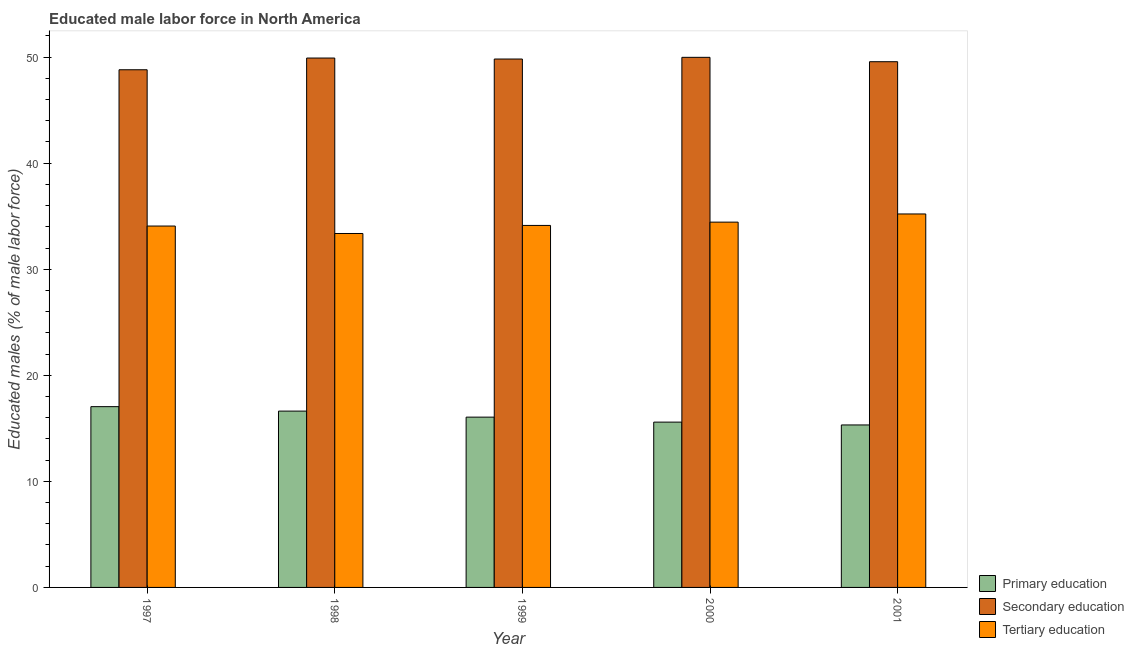How many groups of bars are there?
Your answer should be very brief. 5. Are the number of bars per tick equal to the number of legend labels?
Your answer should be very brief. Yes. Are the number of bars on each tick of the X-axis equal?
Ensure brevity in your answer.  Yes. How many bars are there on the 4th tick from the left?
Provide a succinct answer. 3. How many bars are there on the 5th tick from the right?
Ensure brevity in your answer.  3. What is the label of the 2nd group of bars from the left?
Keep it short and to the point. 1998. In how many cases, is the number of bars for a given year not equal to the number of legend labels?
Your answer should be very brief. 0. What is the percentage of male labor force who received secondary education in 2000?
Ensure brevity in your answer.  49.98. Across all years, what is the maximum percentage of male labor force who received primary education?
Provide a short and direct response. 17.04. Across all years, what is the minimum percentage of male labor force who received secondary education?
Your answer should be compact. 48.81. In which year was the percentage of male labor force who received secondary education minimum?
Your answer should be compact. 1997. What is the total percentage of male labor force who received secondary education in the graph?
Offer a very short reply. 248.07. What is the difference between the percentage of male labor force who received secondary education in 1998 and that in 1999?
Your response must be concise. 0.09. What is the difference between the percentage of male labor force who received primary education in 1997 and the percentage of male labor force who received tertiary education in 1998?
Your response must be concise. 0.42. What is the average percentage of male labor force who received tertiary education per year?
Your answer should be very brief. 34.24. In the year 1999, what is the difference between the percentage of male labor force who received primary education and percentage of male labor force who received tertiary education?
Your response must be concise. 0. What is the ratio of the percentage of male labor force who received tertiary education in 1998 to that in 2000?
Offer a very short reply. 0.97. What is the difference between the highest and the second highest percentage of male labor force who received tertiary education?
Your answer should be very brief. 0.77. What is the difference between the highest and the lowest percentage of male labor force who received primary education?
Offer a terse response. 1.73. In how many years, is the percentage of male labor force who received secondary education greater than the average percentage of male labor force who received secondary education taken over all years?
Give a very brief answer. 3. What does the 3rd bar from the left in 1998 represents?
Offer a very short reply. Tertiary education. What does the 2nd bar from the right in 1998 represents?
Ensure brevity in your answer.  Secondary education. Is it the case that in every year, the sum of the percentage of male labor force who received primary education and percentage of male labor force who received secondary education is greater than the percentage of male labor force who received tertiary education?
Your response must be concise. Yes. Are all the bars in the graph horizontal?
Ensure brevity in your answer.  No. How many years are there in the graph?
Ensure brevity in your answer.  5. Where does the legend appear in the graph?
Keep it short and to the point. Bottom right. How many legend labels are there?
Make the answer very short. 3. How are the legend labels stacked?
Offer a very short reply. Vertical. What is the title of the graph?
Provide a short and direct response. Educated male labor force in North America. What is the label or title of the X-axis?
Give a very brief answer. Year. What is the label or title of the Y-axis?
Make the answer very short. Educated males (% of male labor force). What is the Educated males (% of male labor force) in Primary education in 1997?
Your response must be concise. 17.04. What is the Educated males (% of male labor force) of Secondary education in 1997?
Provide a short and direct response. 48.81. What is the Educated males (% of male labor force) in Tertiary education in 1997?
Make the answer very short. 34.07. What is the Educated males (% of male labor force) in Primary education in 1998?
Ensure brevity in your answer.  16.62. What is the Educated males (% of male labor force) in Secondary education in 1998?
Make the answer very short. 49.91. What is the Educated males (% of male labor force) in Tertiary education in 1998?
Provide a succinct answer. 33.37. What is the Educated males (% of male labor force) of Primary education in 1999?
Ensure brevity in your answer.  16.05. What is the Educated males (% of male labor force) of Secondary education in 1999?
Offer a very short reply. 49.82. What is the Educated males (% of male labor force) in Tertiary education in 1999?
Your answer should be compact. 34.13. What is the Educated males (% of male labor force) in Primary education in 2000?
Your answer should be very brief. 15.59. What is the Educated males (% of male labor force) of Secondary education in 2000?
Your response must be concise. 49.98. What is the Educated males (% of male labor force) of Tertiary education in 2000?
Provide a succinct answer. 34.44. What is the Educated males (% of male labor force) in Primary education in 2001?
Give a very brief answer. 15.32. What is the Educated males (% of male labor force) in Secondary education in 2001?
Your answer should be compact. 49.56. What is the Educated males (% of male labor force) in Tertiary education in 2001?
Your answer should be compact. 35.21. Across all years, what is the maximum Educated males (% of male labor force) of Primary education?
Your answer should be compact. 17.04. Across all years, what is the maximum Educated males (% of male labor force) in Secondary education?
Your answer should be very brief. 49.98. Across all years, what is the maximum Educated males (% of male labor force) of Tertiary education?
Make the answer very short. 35.21. Across all years, what is the minimum Educated males (% of male labor force) of Primary education?
Your response must be concise. 15.32. Across all years, what is the minimum Educated males (% of male labor force) in Secondary education?
Make the answer very short. 48.81. Across all years, what is the minimum Educated males (% of male labor force) of Tertiary education?
Make the answer very short. 33.37. What is the total Educated males (% of male labor force) of Primary education in the graph?
Give a very brief answer. 80.62. What is the total Educated males (% of male labor force) of Secondary education in the graph?
Offer a very short reply. 248.07. What is the total Educated males (% of male labor force) in Tertiary education in the graph?
Your answer should be very brief. 171.22. What is the difference between the Educated males (% of male labor force) of Primary education in 1997 and that in 1998?
Give a very brief answer. 0.42. What is the difference between the Educated males (% of male labor force) in Secondary education in 1997 and that in 1998?
Offer a terse response. -1.1. What is the difference between the Educated males (% of male labor force) in Tertiary education in 1997 and that in 1998?
Give a very brief answer. 0.7. What is the difference between the Educated males (% of male labor force) in Secondary education in 1997 and that in 1999?
Offer a very short reply. -1.01. What is the difference between the Educated males (% of male labor force) of Tertiary education in 1997 and that in 1999?
Give a very brief answer. -0.06. What is the difference between the Educated males (% of male labor force) in Primary education in 1997 and that in 2000?
Provide a succinct answer. 1.46. What is the difference between the Educated males (% of male labor force) of Secondary education in 1997 and that in 2000?
Your answer should be compact. -1.17. What is the difference between the Educated males (% of male labor force) in Tertiary education in 1997 and that in 2000?
Offer a very short reply. -0.37. What is the difference between the Educated males (% of male labor force) in Primary education in 1997 and that in 2001?
Your answer should be very brief. 1.73. What is the difference between the Educated males (% of male labor force) in Secondary education in 1997 and that in 2001?
Offer a very short reply. -0.76. What is the difference between the Educated males (% of male labor force) of Tertiary education in 1997 and that in 2001?
Give a very brief answer. -1.14. What is the difference between the Educated males (% of male labor force) in Primary education in 1998 and that in 1999?
Your answer should be compact. 0.57. What is the difference between the Educated males (% of male labor force) of Secondary education in 1998 and that in 1999?
Your response must be concise. 0.09. What is the difference between the Educated males (% of male labor force) of Tertiary education in 1998 and that in 1999?
Offer a terse response. -0.76. What is the difference between the Educated males (% of male labor force) in Primary education in 1998 and that in 2000?
Your answer should be compact. 1.04. What is the difference between the Educated males (% of male labor force) in Secondary education in 1998 and that in 2000?
Give a very brief answer. -0.07. What is the difference between the Educated males (% of male labor force) in Tertiary education in 1998 and that in 2000?
Your answer should be very brief. -1.07. What is the difference between the Educated males (% of male labor force) in Primary education in 1998 and that in 2001?
Your answer should be very brief. 1.31. What is the difference between the Educated males (% of male labor force) of Secondary education in 1998 and that in 2001?
Your response must be concise. 0.35. What is the difference between the Educated males (% of male labor force) in Tertiary education in 1998 and that in 2001?
Provide a succinct answer. -1.84. What is the difference between the Educated males (% of male labor force) of Primary education in 1999 and that in 2000?
Offer a very short reply. 0.47. What is the difference between the Educated males (% of male labor force) in Secondary education in 1999 and that in 2000?
Offer a very short reply. -0.16. What is the difference between the Educated males (% of male labor force) of Tertiary education in 1999 and that in 2000?
Make the answer very short. -0.31. What is the difference between the Educated males (% of male labor force) of Primary education in 1999 and that in 2001?
Your answer should be compact. 0.74. What is the difference between the Educated males (% of male labor force) of Secondary education in 1999 and that in 2001?
Provide a succinct answer. 0.25. What is the difference between the Educated males (% of male labor force) of Tertiary education in 1999 and that in 2001?
Your answer should be very brief. -1.08. What is the difference between the Educated males (% of male labor force) of Primary education in 2000 and that in 2001?
Provide a short and direct response. 0.27. What is the difference between the Educated males (% of male labor force) in Secondary education in 2000 and that in 2001?
Provide a succinct answer. 0.41. What is the difference between the Educated males (% of male labor force) of Tertiary education in 2000 and that in 2001?
Offer a terse response. -0.77. What is the difference between the Educated males (% of male labor force) of Primary education in 1997 and the Educated males (% of male labor force) of Secondary education in 1998?
Keep it short and to the point. -32.87. What is the difference between the Educated males (% of male labor force) of Primary education in 1997 and the Educated males (% of male labor force) of Tertiary education in 1998?
Give a very brief answer. -16.32. What is the difference between the Educated males (% of male labor force) in Secondary education in 1997 and the Educated males (% of male labor force) in Tertiary education in 1998?
Provide a succinct answer. 15.44. What is the difference between the Educated males (% of male labor force) of Primary education in 1997 and the Educated males (% of male labor force) of Secondary education in 1999?
Keep it short and to the point. -32.77. What is the difference between the Educated males (% of male labor force) in Primary education in 1997 and the Educated males (% of male labor force) in Tertiary education in 1999?
Ensure brevity in your answer.  -17.08. What is the difference between the Educated males (% of male labor force) in Secondary education in 1997 and the Educated males (% of male labor force) in Tertiary education in 1999?
Offer a very short reply. 14.68. What is the difference between the Educated males (% of male labor force) of Primary education in 1997 and the Educated males (% of male labor force) of Secondary education in 2000?
Give a very brief answer. -32.93. What is the difference between the Educated males (% of male labor force) of Primary education in 1997 and the Educated males (% of male labor force) of Tertiary education in 2000?
Offer a terse response. -17.39. What is the difference between the Educated males (% of male labor force) of Secondary education in 1997 and the Educated males (% of male labor force) of Tertiary education in 2000?
Your answer should be compact. 14.37. What is the difference between the Educated males (% of male labor force) in Primary education in 1997 and the Educated males (% of male labor force) in Secondary education in 2001?
Offer a terse response. -32.52. What is the difference between the Educated males (% of male labor force) in Primary education in 1997 and the Educated males (% of male labor force) in Tertiary education in 2001?
Your response must be concise. -18.17. What is the difference between the Educated males (% of male labor force) of Secondary education in 1997 and the Educated males (% of male labor force) of Tertiary education in 2001?
Give a very brief answer. 13.6. What is the difference between the Educated males (% of male labor force) in Primary education in 1998 and the Educated males (% of male labor force) in Secondary education in 1999?
Give a very brief answer. -33.19. What is the difference between the Educated males (% of male labor force) of Primary education in 1998 and the Educated males (% of male labor force) of Tertiary education in 1999?
Offer a terse response. -17.51. What is the difference between the Educated males (% of male labor force) in Secondary education in 1998 and the Educated males (% of male labor force) in Tertiary education in 1999?
Keep it short and to the point. 15.78. What is the difference between the Educated males (% of male labor force) in Primary education in 1998 and the Educated males (% of male labor force) in Secondary education in 2000?
Provide a short and direct response. -33.35. What is the difference between the Educated males (% of male labor force) in Primary education in 1998 and the Educated males (% of male labor force) in Tertiary education in 2000?
Provide a succinct answer. -17.82. What is the difference between the Educated males (% of male labor force) of Secondary education in 1998 and the Educated males (% of male labor force) of Tertiary education in 2000?
Offer a very short reply. 15.47. What is the difference between the Educated males (% of male labor force) of Primary education in 1998 and the Educated males (% of male labor force) of Secondary education in 2001?
Give a very brief answer. -32.94. What is the difference between the Educated males (% of male labor force) in Primary education in 1998 and the Educated males (% of male labor force) in Tertiary education in 2001?
Offer a terse response. -18.59. What is the difference between the Educated males (% of male labor force) of Secondary education in 1998 and the Educated males (% of male labor force) of Tertiary education in 2001?
Your response must be concise. 14.7. What is the difference between the Educated males (% of male labor force) of Primary education in 1999 and the Educated males (% of male labor force) of Secondary education in 2000?
Offer a terse response. -33.92. What is the difference between the Educated males (% of male labor force) in Primary education in 1999 and the Educated males (% of male labor force) in Tertiary education in 2000?
Keep it short and to the point. -18.38. What is the difference between the Educated males (% of male labor force) in Secondary education in 1999 and the Educated males (% of male labor force) in Tertiary education in 2000?
Provide a succinct answer. 15.38. What is the difference between the Educated males (% of male labor force) of Primary education in 1999 and the Educated males (% of male labor force) of Secondary education in 2001?
Make the answer very short. -33.51. What is the difference between the Educated males (% of male labor force) in Primary education in 1999 and the Educated males (% of male labor force) in Tertiary education in 2001?
Your answer should be compact. -19.15. What is the difference between the Educated males (% of male labor force) in Secondary education in 1999 and the Educated males (% of male labor force) in Tertiary education in 2001?
Your answer should be compact. 14.61. What is the difference between the Educated males (% of male labor force) in Primary education in 2000 and the Educated males (% of male labor force) in Secondary education in 2001?
Offer a terse response. -33.98. What is the difference between the Educated males (% of male labor force) of Primary education in 2000 and the Educated males (% of male labor force) of Tertiary education in 2001?
Your response must be concise. -19.62. What is the difference between the Educated males (% of male labor force) in Secondary education in 2000 and the Educated males (% of male labor force) in Tertiary education in 2001?
Your response must be concise. 14.77. What is the average Educated males (% of male labor force) of Primary education per year?
Provide a short and direct response. 16.12. What is the average Educated males (% of male labor force) in Secondary education per year?
Your answer should be compact. 49.61. What is the average Educated males (% of male labor force) in Tertiary education per year?
Make the answer very short. 34.24. In the year 1997, what is the difference between the Educated males (% of male labor force) of Primary education and Educated males (% of male labor force) of Secondary education?
Your answer should be very brief. -31.76. In the year 1997, what is the difference between the Educated males (% of male labor force) in Primary education and Educated males (% of male labor force) in Tertiary education?
Ensure brevity in your answer.  -17.03. In the year 1997, what is the difference between the Educated males (% of male labor force) of Secondary education and Educated males (% of male labor force) of Tertiary education?
Provide a succinct answer. 14.73. In the year 1998, what is the difference between the Educated males (% of male labor force) in Primary education and Educated males (% of male labor force) in Secondary education?
Ensure brevity in your answer.  -33.29. In the year 1998, what is the difference between the Educated males (% of male labor force) in Primary education and Educated males (% of male labor force) in Tertiary education?
Your answer should be compact. -16.74. In the year 1998, what is the difference between the Educated males (% of male labor force) in Secondary education and Educated males (% of male labor force) in Tertiary education?
Give a very brief answer. 16.54. In the year 1999, what is the difference between the Educated males (% of male labor force) of Primary education and Educated males (% of male labor force) of Secondary education?
Provide a succinct answer. -33.76. In the year 1999, what is the difference between the Educated males (% of male labor force) of Primary education and Educated males (% of male labor force) of Tertiary education?
Provide a short and direct response. -18.07. In the year 1999, what is the difference between the Educated males (% of male labor force) of Secondary education and Educated males (% of male labor force) of Tertiary education?
Offer a terse response. 15.69. In the year 2000, what is the difference between the Educated males (% of male labor force) in Primary education and Educated males (% of male labor force) in Secondary education?
Offer a very short reply. -34.39. In the year 2000, what is the difference between the Educated males (% of male labor force) of Primary education and Educated males (% of male labor force) of Tertiary education?
Ensure brevity in your answer.  -18.85. In the year 2000, what is the difference between the Educated males (% of male labor force) of Secondary education and Educated males (% of male labor force) of Tertiary education?
Provide a succinct answer. 15.54. In the year 2001, what is the difference between the Educated males (% of male labor force) in Primary education and Educated males (% of male labor force) in Secondary education?
Offer a terse response. -34.24. In the year 2001, what is the difference between the Educated males (% of male labor force) in Primary education and Educated males (% of male labor force) in Tertiary education?
Give a very brief answer. -19.89. In the year 2001, what is the difference between the Educated males (% of male labor force) in Secondary education and Educated males (% of male labor force) in Tertiary education?
Provide a succinct answer. 14.35. What is the ratio of the Educated males (% of male labor force) in Primary education in 1997 to that in 1998?
Offer a terse response. 1.03. What is the ratio of the Educated males (% of male labor force) of Secondary education in 1997 to that in 1998?
Provide a short and direct response. 0.98. What is the ratio of the Educated males (% of male labor force) of Tertiary education in 1997 to that in 1998?
Provide a short and direct response. 1.02. What is the ratio of the Educated males (% of male labor force) in Primary education in 1997 to that in 1999?
Offer a terse response. 1.06. What is the ratio of the Educated males (% of male labor force) in Secondary education in 1997 to that in 1999?
Your answer should be compact. 0.98. What is the ratio of the Educated males (% of male labor force) in Primary education in 1997 to that in 2000?
Make the answer very short. 1.09. What is the ratio of the Educated males (% of male labor force) in Secondary education in 1997 to that in 2000?
Provide a short and direct response. 0.98. What is the ratio of the Educated males (% of male labor force) in Tertiary education in 1997 to that in 2000?
Offer a terse response. 0.99. What is the ratio of the Educated males (% of male labor force) in Primary education in 1997 to that in 2001?
Your response must be concise. 1.11. What is the ratio of the Educated males (% of male labor force) in Secondary education in 1997 to that in 2001?
Provide a succinct answer. 0.98. What is the ratio of the Educated males (% of male labor force) of Primary education in 1998 to that in 1999?
Your answer should be very brief. 1.04. What is the ratio of the Educated males (% of male labor force) in Secondary education in 1998 to that in 1999?
Give a very brief answer. 1. What is the ratio of the Educated males (% of male labor force) in Tertiary education in 1998 to that in 1999?
Offer a very short reply. 0.98. What is the ratio of the Educated males (% of male labor force) in Primary education in 1998 to that in 2000?
Offer a very short reply. 1.07. What is the ratio of the Educated males (% of male labor force) of Tertiary education in 1998 to that in 2000?
Give a very brief answer. 0.97. What is the ratio of the Educated males (% of male labor force) of Primary education in 1998 to that in 2001?
Your answer should be very brief. 1.09. What is the ratio of the Educated males (% of male labor force) in Secondary education in 1998 to that in 2001?
Offer a terse response. 1.01. What is the ratio of the Educated males (% of male labor force) in Tertiary education in 1998 to that in 2001?
Make the answer very short. 0.95. What is the ratio of the Educated males (% of male labor force) in Primary education in 1999 to that in 2000?
Your answer should be very brief. 1.03. What is the ratio of the Educated males (% of male labor force) of Secondary education in 1999 to that in 2000?
Your answer should be very brief. 1. What is the ratio of the Educated males (% of male labor force) of Tertiary education in 1999 to that in 2000?
Keep it short and to the point. 0.99. What is the ratio of the Educated males (% of male labor force) in Primary education in 1999 to that in 2001?
Give a very brief answer. 1.05. What is the ratio of the Educated males (% of male labor force) in Secondary education in 1999 to that in 2001?
Keep it short and to the point. 1.01. What is the ratio of the Educated males (% of male labor force) in Tertiary education in 1999 to that in 2001?
Your answer should be very brief. 0.97. What is the ratio of the Educated males (% of male labor force) in Primary education in 2000 to that in 2001?
Offer a very short reply. 1.02. What is the ratio of the Educated males (% of male labor force) of Secondary education in 2000 to that in 2001?
Offer a terse response. 1.01. What is the ratio of the Educated males (% of male labor force) of Tertiary education in 2000 to that in 2001?
Provide a short and direct response. 0.98. What is the difference between the highest and the second highest Educated males (% of male labor force) in Primary education?
Give a very brief answer. 0.42. What is the difference between the highest and the second highest Educated males (% of male labor force) of Secondary education?
Provide a short and direct response. 0.07. What is the difference between the highest and the second highest Educated males (% of male labor force) of Tertiary education?
Give a very brief answer. 0.77. What is the difference between the highest and the lowest Educated males (% of male labor force) in Primary education?
Your answer should be very brief. 1.73. What is the difference between the highest and the lowest Educated males (% of male labor force) of Secondary education?
Give a very brief answer. 1.17. What is the difference between the highest and the lowest Educated males (% of male labor force) of Tertiary education?
Offer a terse response. 1.84. 